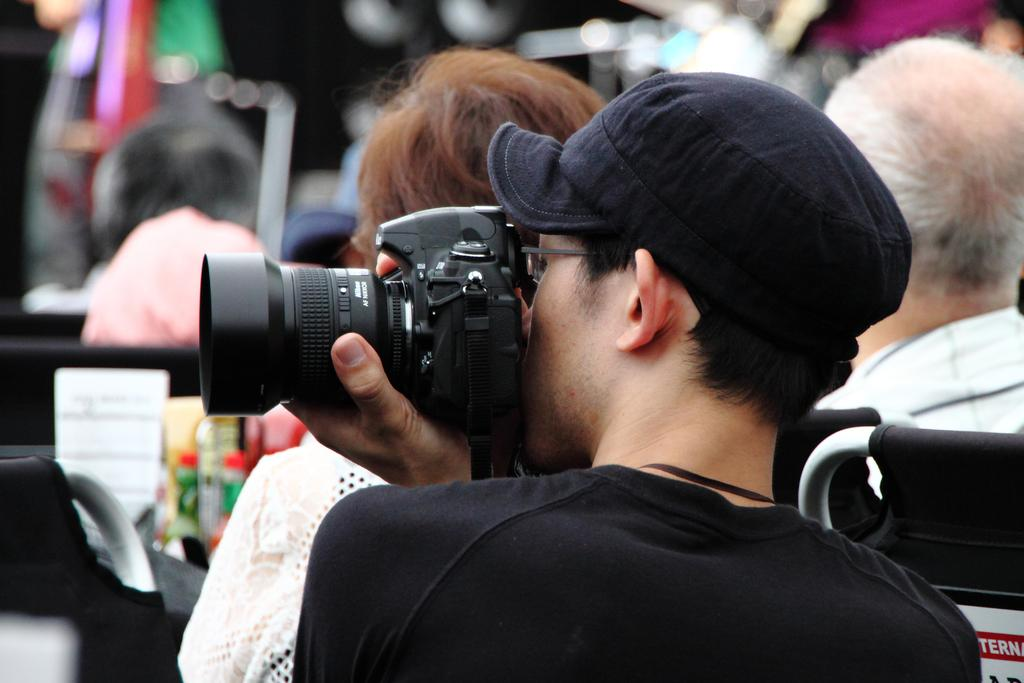What is the person in the image wearing on their upper body? The person is wearing a black T-shirt. What type of headwear is the person wearing? The person is wearing a black cap. What is the person holding in their left hand? The person is holding a camera in their left hand. Can you describe the group of persons in the background of the image? There is a group of persons in the background of the image, but no specific details about them are provided. What type of toy is the person's aunt holding in the image? There is no mention of an aunt or a toy in the image, so this question cannot be answered. 